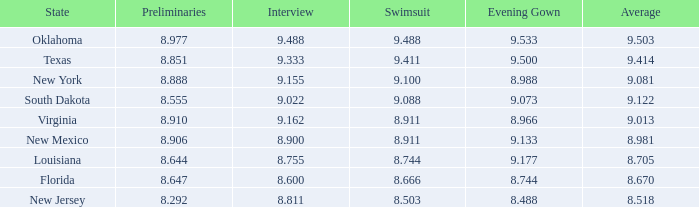670? 8.666. 